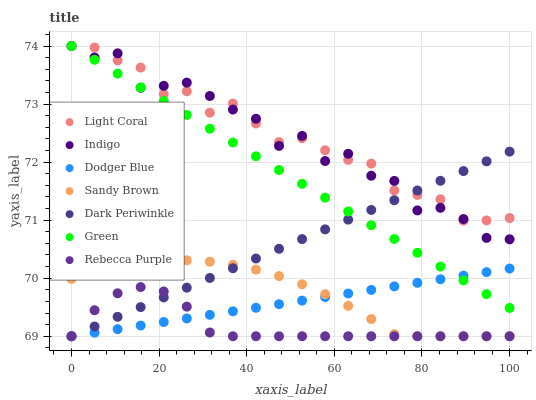Does Rebecca Purple have the minimum area under the curve?
Answer yes or no. Yes. Does Light Coral have the maximum area under the curve?
Answer yes or no. Yes. Does Dodger Blue have the minimum area under the curve?
Answer yes or no. No. Does Dodger Blue have the maximum area under the curve?
Answer yes or no. No. Is Green the smoothest?
Answer yes or no. Yes. Is Indigo the roughest?
Answer yes or no. Yes. Is Light Coral the smoothest?
Answer yes or no. No. Is Light Coral the roughest?
Answer yes or no. No. Does Dodger Blue have the lowest value?
Answer yes or no. Yes. Does Light Coral have the lowest value?
Answer yes or no. No. Does Green have the highest value?
Answer yes or no. Yes. Does Dodger Blue have the highest value?
Answer yes or no. No. Is Rebecca Purple less than Light Coral?
Answer yes or no. Yes. Is Green greater than Sandy Brown?
Answer yes or no. Yes. Does Dark Periwinkle intersect Green?
Answer yes or no. Yes. Is Dark Periwinkle less than Green?
Answer yes or no. No. Is Dark Periwinkle greater than Green?
Answer yes or no. No. Does Rebecca Purple intersect Light Coral?
Answer yes or no. No. 